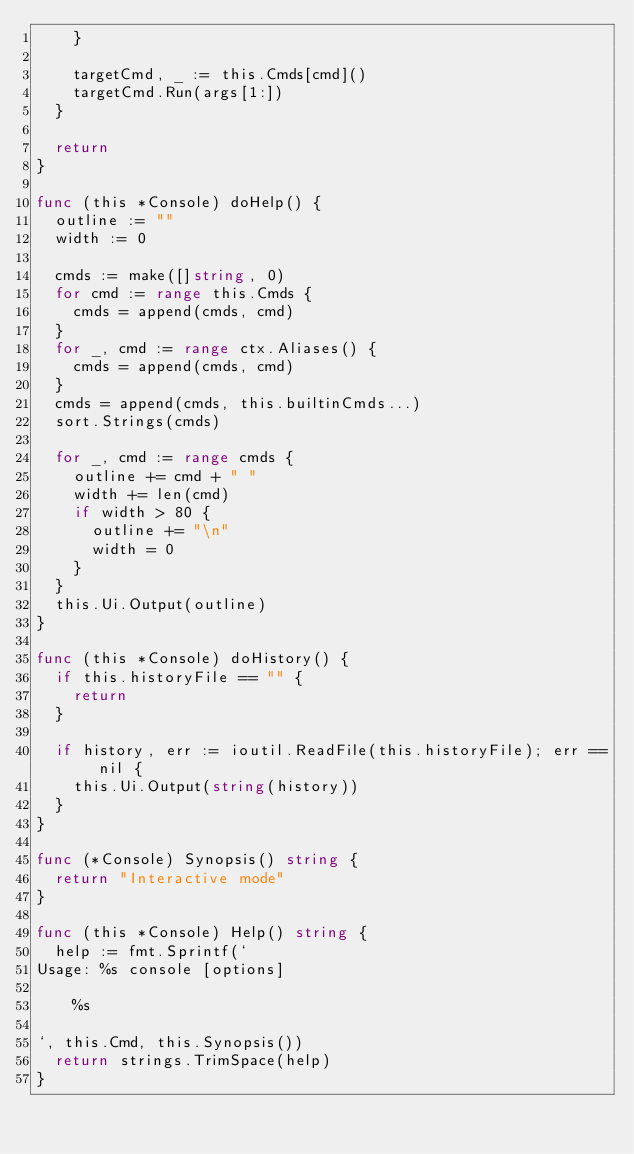<code> <loc_0><loc_0><loc_500><loc_500><_Go_>		}

		targetCmd, _ := this.Cmds[cmd]()
		targetCmd.Run(args[1:])
	}

	return
}

func (this *Console) doHelp() {
	outline := ""
	width := 0

	cmds := make([]string, 0)
	for cmd := range this.Cmds {
		cmds = append(cmds, cmd)
	}
	for _, cmd := range ctx.Aliases() {
		cmds = append(cmds, cmd)
	}
	cmds = append(cmds, this.builtinCmds...)
	sort.Strings(cmds)

	for _, cmd := range cmds {
		outline += cmd + " "
		width += len(cmd)
		if width > 80 {
			outline += "\n"
			width = 0
		}
	}
	this.Ui.Output(outline)
}

func (this *Console) doHistory() {
	if this.historyFile == "" {
		return
	}

	if history, err := ioutil.ReadFile(this.historyFile); err == nil {
		this.Ui.Output(string(history))
	}
}

func (*Console) Synopsis() string {
	return "Interactive mode"
}

func (this *Console) Help() string {
	help := fmt.Sprintf(`
Usage: %s console [options]

    %s

`, this.Cmd, this.Synopsis())
	return strings.TrimSpace(help)
}
</code> 